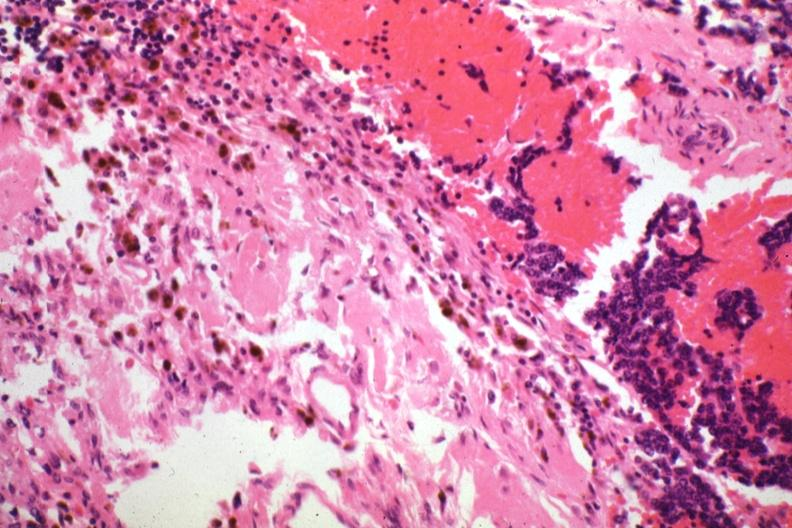s malignant adenoma present?
Answer the question using a single word or phrase. Yes 